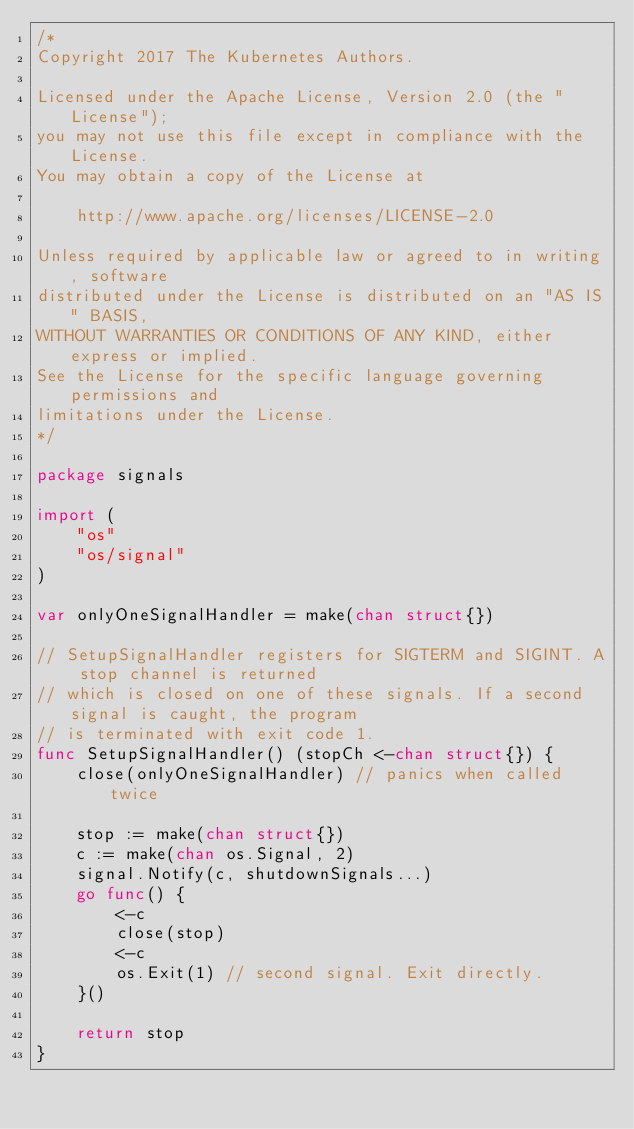Convert code to text. <code><loc_0><loc_0><loc_500><loc_500><_Go_>/*
Copyright 2017 The Kubernetes Authors.

Licensed under the Apache License, Version 2.0 (the "License");
you may not use this file except in compliance with the License.
You may obtain a copy of the License at

    http://www.apache.org/licenses/LICENSE-2.0

Unless required by applicable law or agreed to in writing, software
distributed under the License is distributed on an "AS IS" BASIS,
WITHOUT WARRANTIES OR CONDITIONS OF ANY KIND, either express or implied.
See the License for the specific language governing permissions and
limitations under the License.
*/

package signals

import (
	"os"
	"os/signal"
)

var onlyOneSignalHandler = make(chan struct{})

// SetupSignalHandler registers for SIGTERM and SIGINT. A stop channel is returned
// which is closed on one of these signals. If a second signal is caught, the program
// is terminated with exit code 1.
func SetupSignalHandler() (stopCh <-chan struct{}) {
	close(onlyOneSignalHandler) // panics when called twice

	stop := make(chan struct{})
	c := make(chan os.Signal, 2)
	signal.Notify(c, shutdownSignals...)
	go func() {
		<-c
		close(stop)
		<-c
		os.Exit(1) // second signal. Exit directly.
	}()

	return stop
}
</code> 